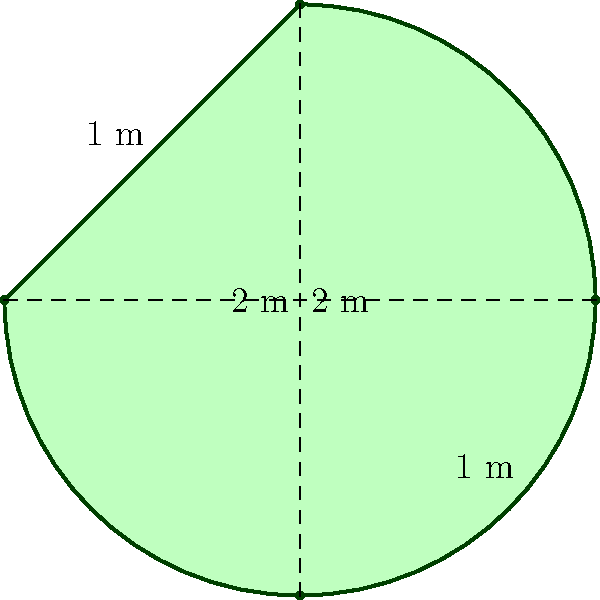You've decided to create a musical note-shaped garden to inspire your students. The garden is shaped like a quarter note, with curved sides and a straight top and bottom. The height of the garden is 2 meters, and the width at the widest point is also 2 meters. The curved sides extend 1 meter from the center line on each side. Estimate the area of this garden to the nearest square meter. To estimate the area of this musical note-shaped garden, we can follow these steps:

1) First, let's consider the shape as a rectangle with curved sides. The straight top and bottom are 2 meters apart.

2) The width varies due to the curves, but at its widest point, it's also 2 meters.

3) To approximate the area, we can use the formula for the area of an ellipse, which is similar to our shape:

   $$A = \pi \cdot a \cdot b$$

   Where $a$ is half the width and $b$ is half the height.

4) In this case:
   $a = 1$ meter (half of 2 meters)
   $b = 1$ meter (half of 2 meters)

5) Plugging these values into the formula:

   $$A = \pi \cdot 1 \cdot 1 = \pi$$

6) $\pi$ is approximately 3.14159

7) Therefore, the estimated area is approximately 3.14159 square meters.

8) Rounding to the nearest square meter, we get 3 square meters.

This method provides a reasonable estimate, although the actual area might be slightly different due to the specific curvature of the sides.
Answer: 3 square meters 